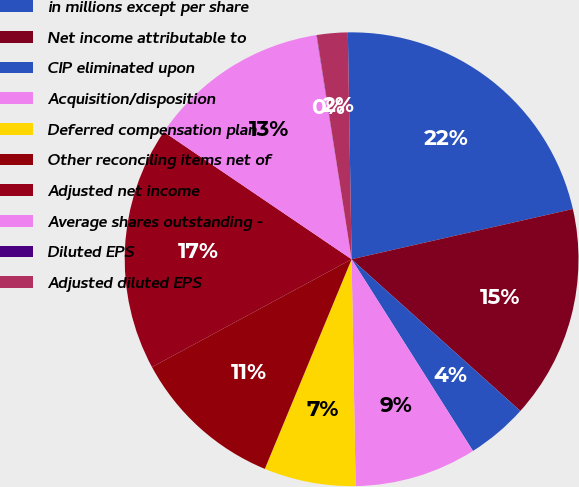Convert chart. <chart><loc_0><loc_0><loc_500><loc_500><pie_chart><fcel>in millions except per share<fcel>Net income attributable to<fcel>CIP eliminated upon<fcel>Acquisition/disposition<fcel>Deferred compensation plan<fcel>Other reconciling items net of<fcel>Adjusted net income<fcel>Average shares outstanding -<fcel>Diluted EPS<fcel>Adjusted diluted EPS<nl><fcel>21.71%<fcel>15.21%<fcel>4.36%<fcel>8.7%<fcel>6.53%<fcel>10.87%<fcel>17.37%<fcel>13.04%<fcel>0.02%<fcel>2.19%<nl></chart> 